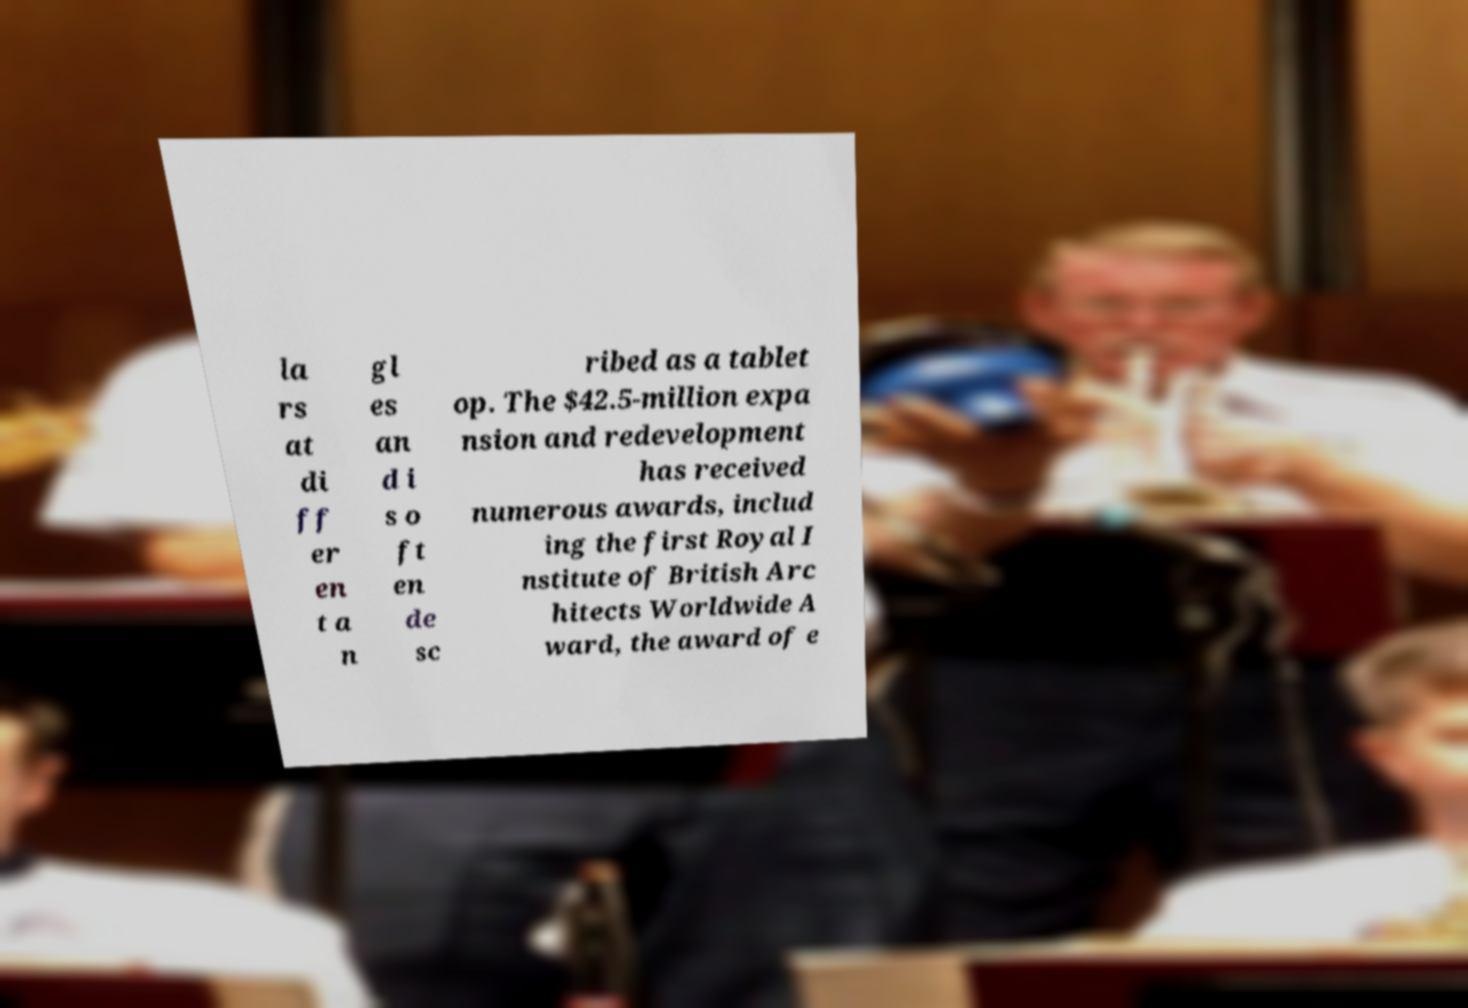Please identify and transcribe the text found in this image. la rs at di ff er en t a n gl es an d i s o ft en de sc ribed as a tablet op. The $42.5-million expa nsion and redevelopment has received numerous awards, includ ing the first Royal I nstitute of British Arc hitects Worldwide A ward, the award of e 